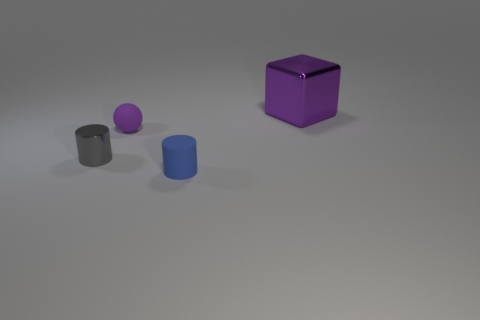Add 1 gray cylinders. How many objects exist? 5 Subtract 1 spheres. How many spheres are left? 0 Subtract all balls. How many objects are left? 3 Subtract all blue cylinders. Subtract all blue blocks. How many cylinders are left? 1 Subtract all purple cubes. How many gray cylinders are left? 1 Subtract all small gray metallic spheres. Subtract all purple blocks. How many objects are left? 3 Add 4 metallic cubes. How many metallic cubes are left? 5 Add 4 big purple things. How many big purple things exist? 5 Subtract 0 red spheres. How many objects are left? 4 